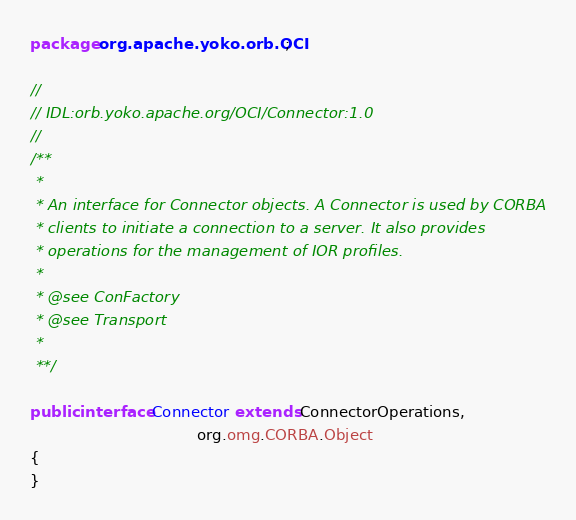<code> <loc_0><loc_0><loc_500><loc_500><_Java_>
package org.apache.yoko.orb.OCI;

//
// IDL:orb.yoko.apache.org/OCI/Connector:1.0
//
/**
 *
 * An interface for Connector objects. A Connector is used by CORBA
 * clients to initiate a connection to a server. It also provides
 * operations for the management of IOR profiles.
 *
 * @see ConFactory
 * @see Transport
 *
 **/

public interface Connector extends ConnectorOperations,
                                   org.omg.CORBA.Object
{
}
</code> 